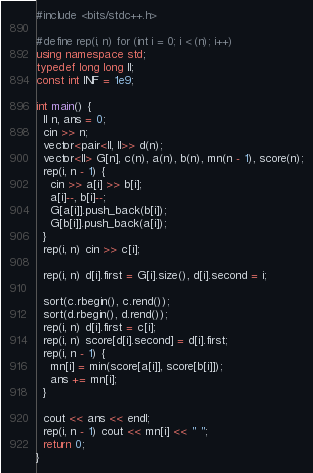Convert code to text. <code><loc_0><loc_0><loc_500><loc_500><_C++_>#include <bits/stdc++.h>

#define rep(i, n) for (int i = 0; i < (n); i++)
using namespace std;
typedef long long ll;
const int INF = 1e9;

int main() {
  ll n, ans = 0;
  cin >> n;
  vector<pair<ll, ll>> d(n);
  vector<ll> G[n], c(n), a(n), b(n), mn(n - 1), score(n);
  rep(i, n - 1) {
    cin >> a[i] >> b[i];
    a[i]--, b[i]--;
    G[a[i]].push_back(b[i]);
    G[b[i]].push_back(a[i]);
  }
  rep(i, n) cin >> c[i];

  rep(i, n) d[i].first = G[i].size(), d[i].second = i;

  sort(c.rbegin(), c.rend());
  sort(d.rbegin(), d.rend());
  rep(i, n) d[i].first = c[i];
  rep(i, n) score[d[i].second] = d[i].first;
  rep(i, n - 1) {
    mn[i] = min(score[a[i]], score[b[i]]);
    ans += mn[i];
  }

  cout << ans << endl;
  rep(i, n - 1) cout << mn[i] << " ";
  return 0;
}
</code> 